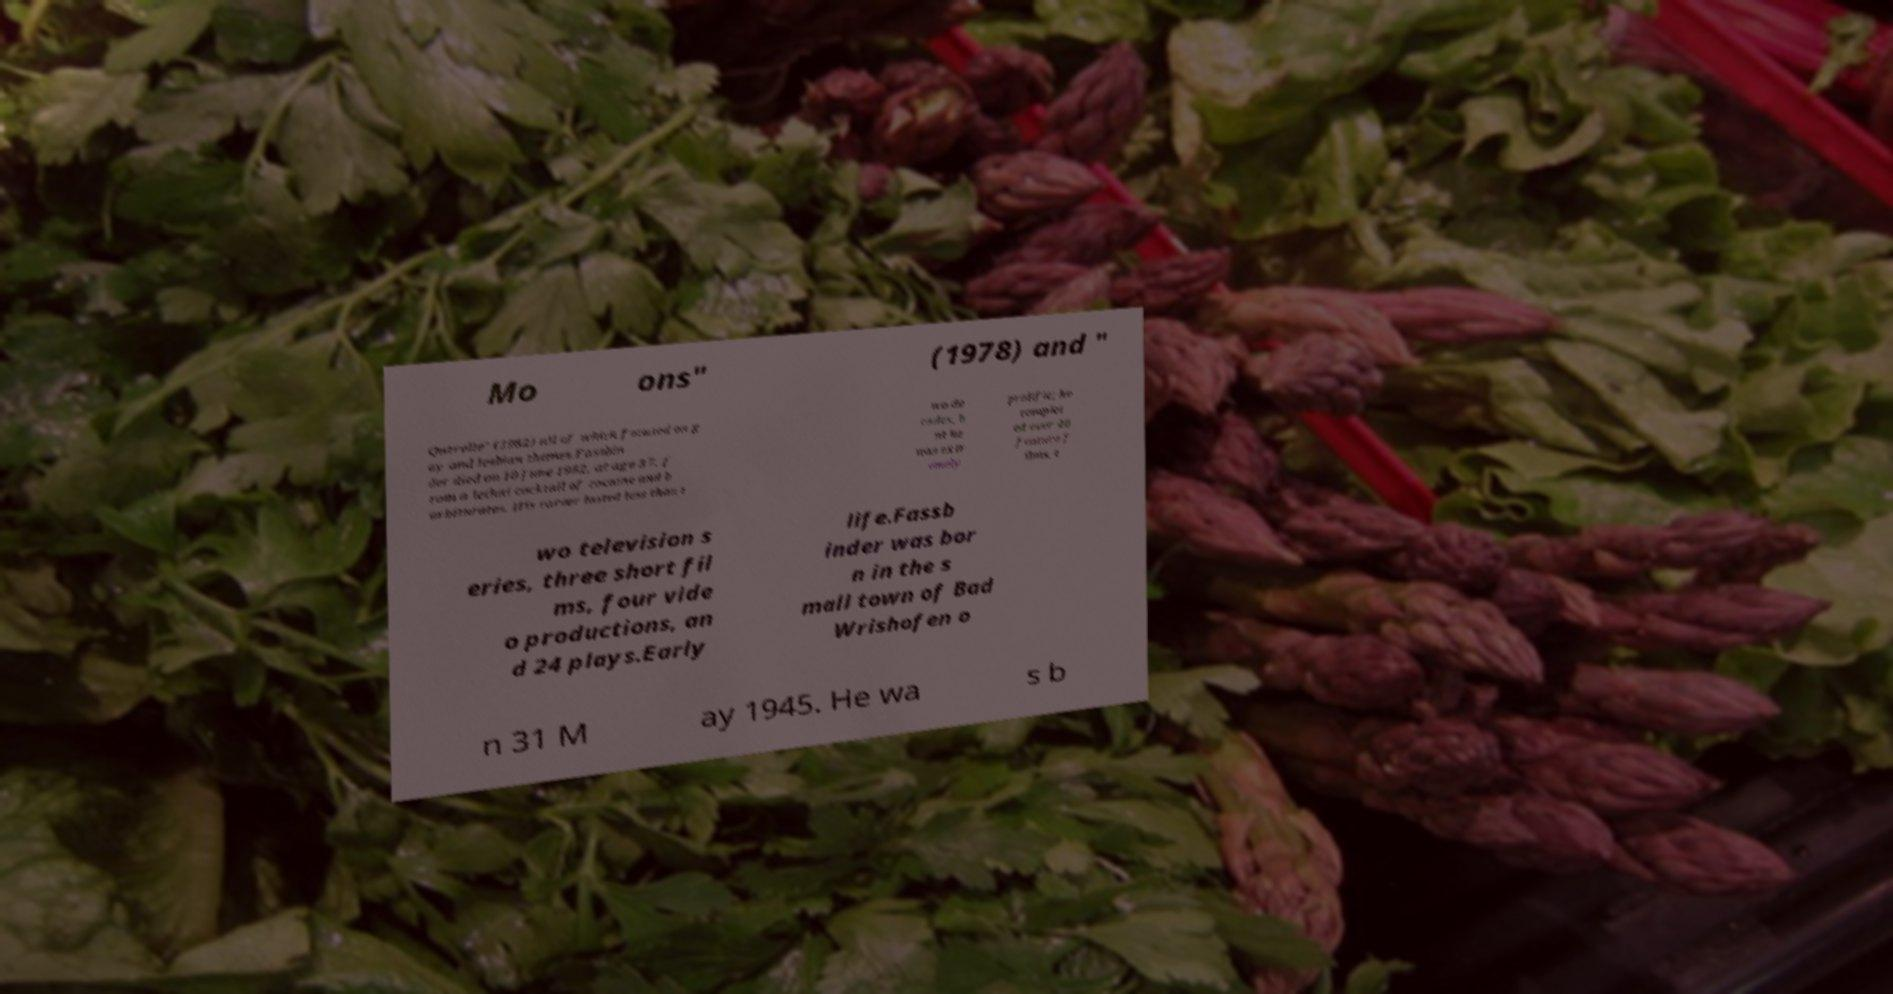Could you assist in decoding the text presented in this image and type it out clearly? Mo ons" (1978) and " Querelle" (1982) all of which focused on g ay and lesbian themes.Fassbin der died on 10 June 1982, at age 37, f rom a lethal cocktail of cocaine and b arbiturates. His career lasted less than t wo de cades, b ut he was extr emely prolific; he complet ed over 40 feature f ilms, t wo television s eries, three short fil ms, four vide o productions, an d 24 plays.Early life.Fassb inder was bor n in the s mall town of Bad Wrishofen o n 31 M ay 1945. He wa s b 